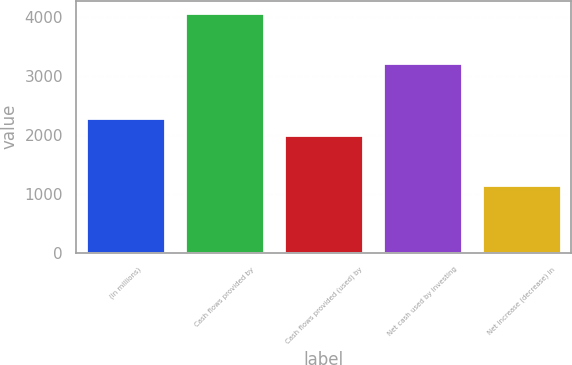<chart> <loc_0><loc_0><loc_500><loc_500><bar_chart><fcel>(in millions)<fcel>Cash flows provided by<fcel>Cash flows provided (used) by<fcel>Net cash used by investing<fcel>Net increase (decrease) in<nl><fcel>2291<fcel>4069<fcel>1999<fcel>3219<fcel>1149<nl></chart> 